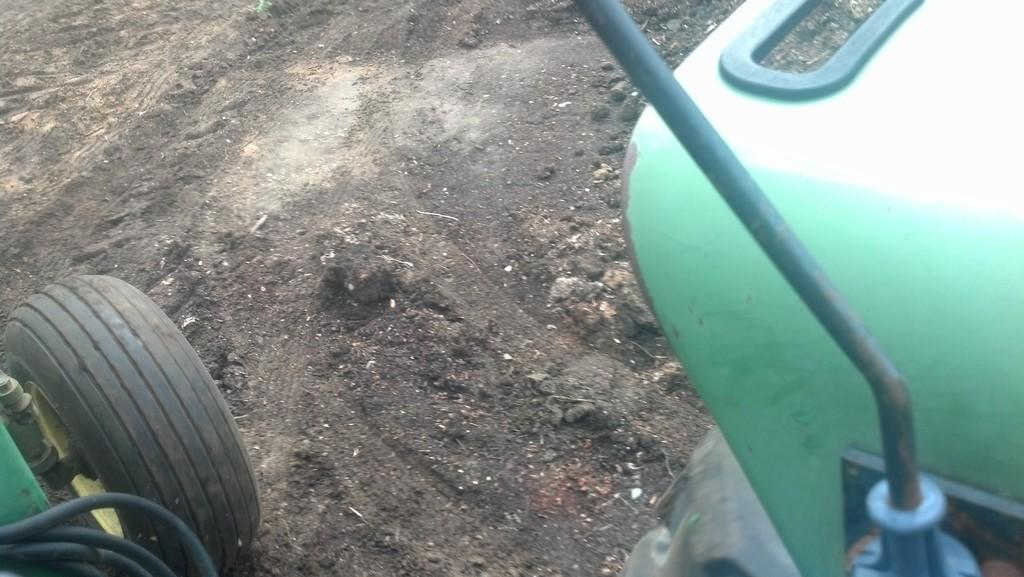What is the main subject of the image? The main subject of the image is a vehicle. What feature of the vehicle is mentioned in the facts? The vehicle has a wheel. Where is the wheel located in relation to the ground? The wheel is on the ground. What type of amusement can be seen on the island in the image? There is no island or amusement present in the image; it features a vehicle with a wheel on the ground. 